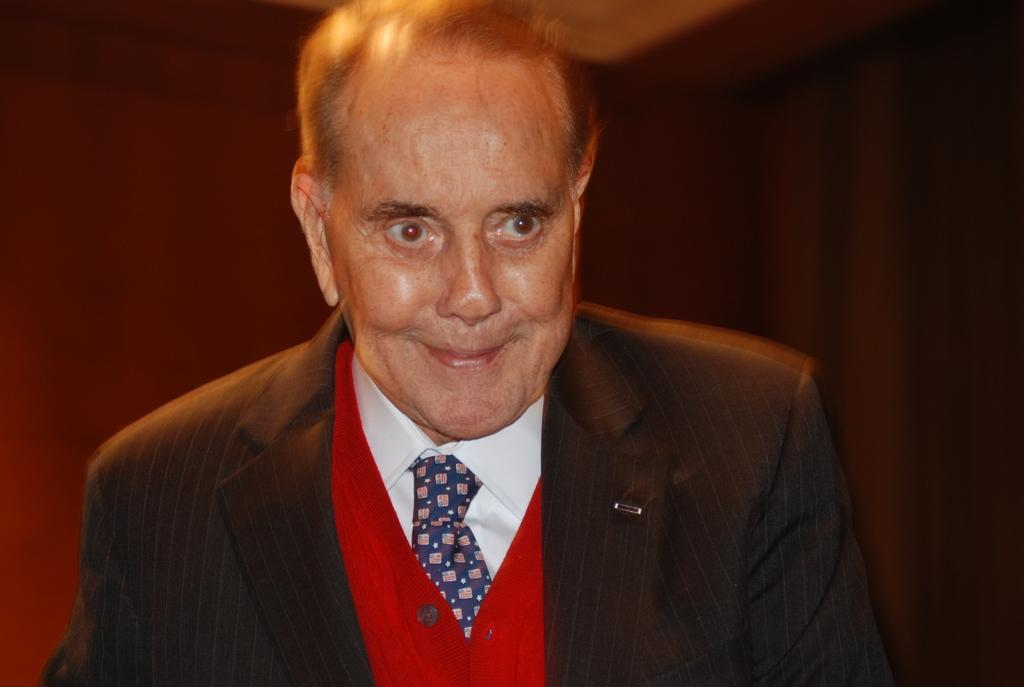Who is the main subject in the image? There is a man in the image. What is the man wearing in the image? The man is wearing a coat and a tie. What can be observed about the background of the image? The background of the image is dark. What type of match is the man playing in the image? There is no match or any sporting activity depicted in the image; it only shows a man wearing a coat and a tie against a dark background. How much dirt is visible on the man's shoes in the image? There is no information about the man's shoes or any dirt on them in the image. 